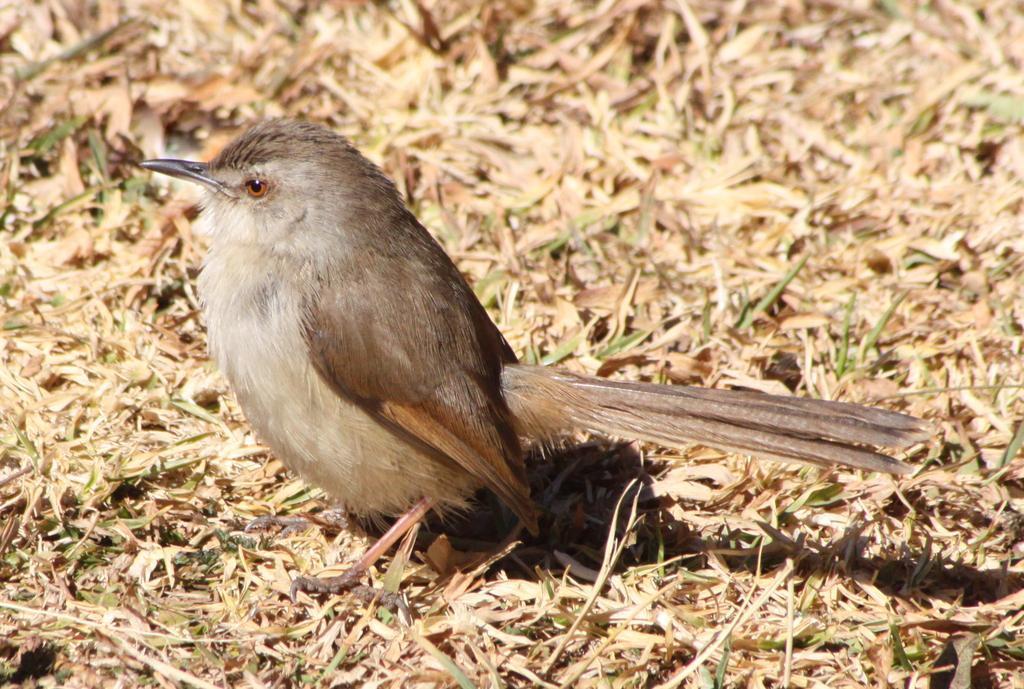How would you summarize this image in a sentence or two? In this picture we can see a bird on the ground and in the background we can see dried leaves. 